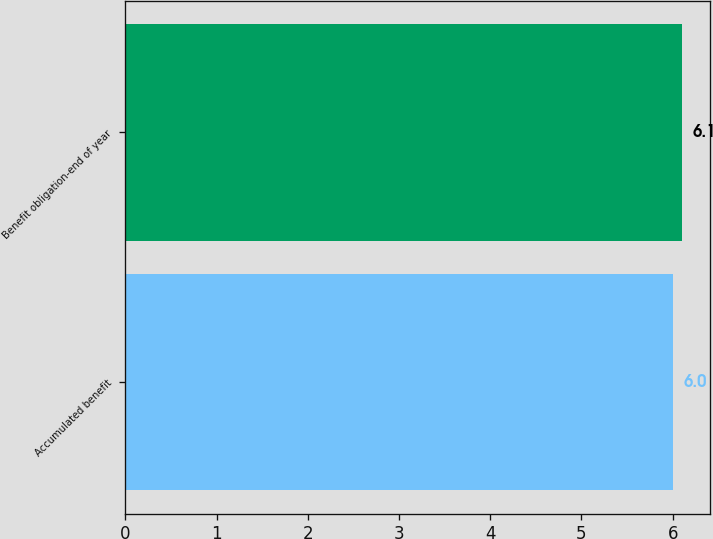Convert chart. <chart><loc_0><loc_0><loc_500><loc_500><bar_chart><fcel>Accumulated benefit<fcel>Benefit obligation-end of year<nl><fcel>6<fcel>6.1<nl></chart> 